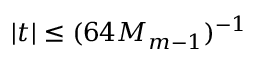<formula> <loc_0><loc_0><loc_500><loc_500>| t | \leq ( 6 4 M _ { m - 1 } ) ^ { - 1 }</formula> 